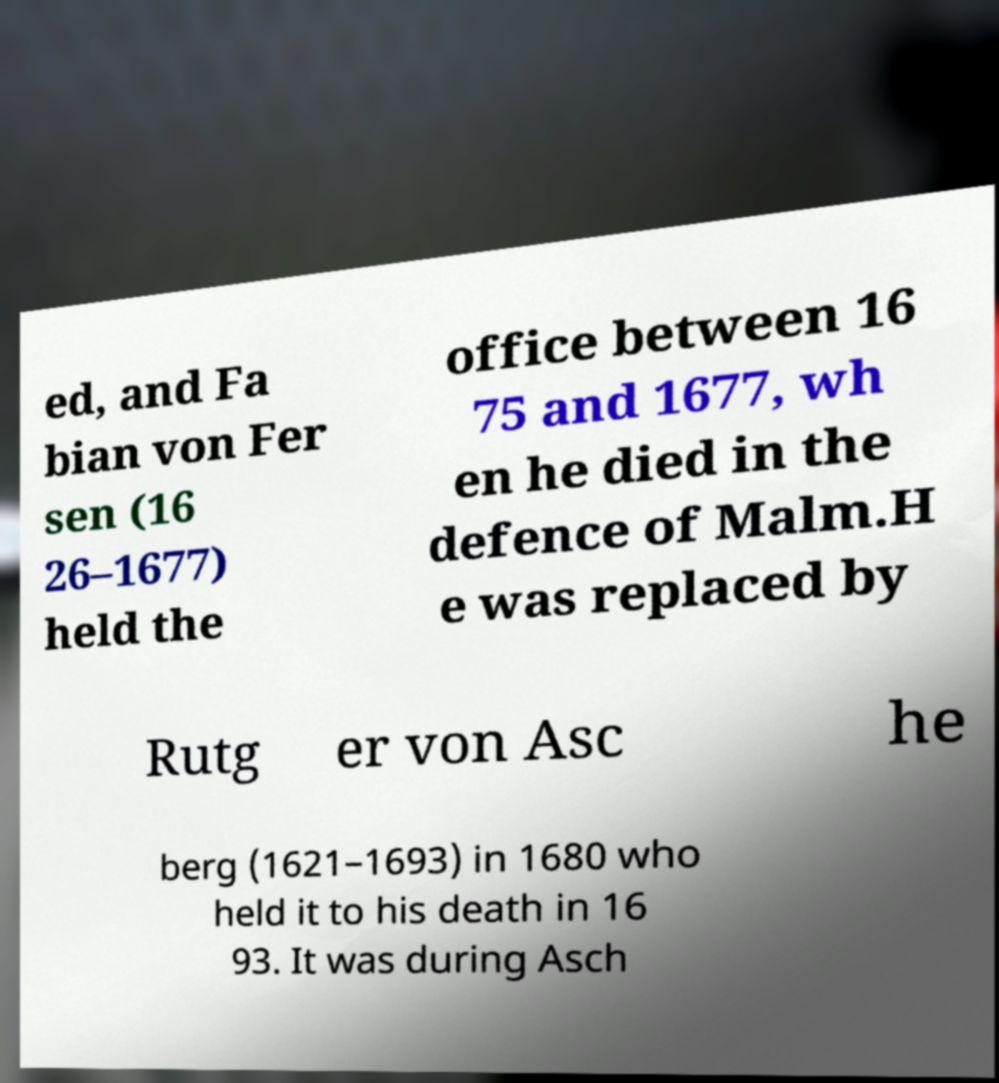Could you assist in decoding the text presented in this image and type it out clearly? ed, and Fa bian von Fer sen (16 26–1677) held the office between 16 75 and 1677, wh en he died in the defence of Malm.H e was replaced by Rutg er von Asc he berg (1621–1693) in 1680 who held it to his death in 16 93. It was during Asch 